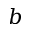Convert formula to latex. <formula><loc_0><loc_0><loc_500><loc_500>b</formula> 